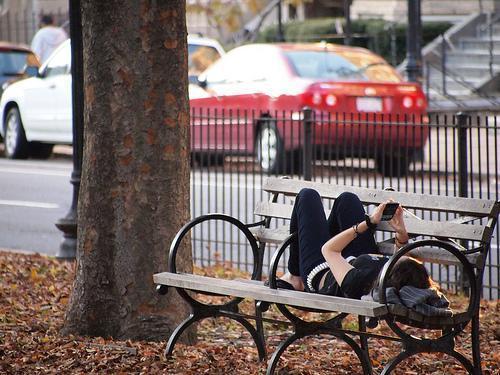How many benches are there?
Give a very brief answer. 1. 